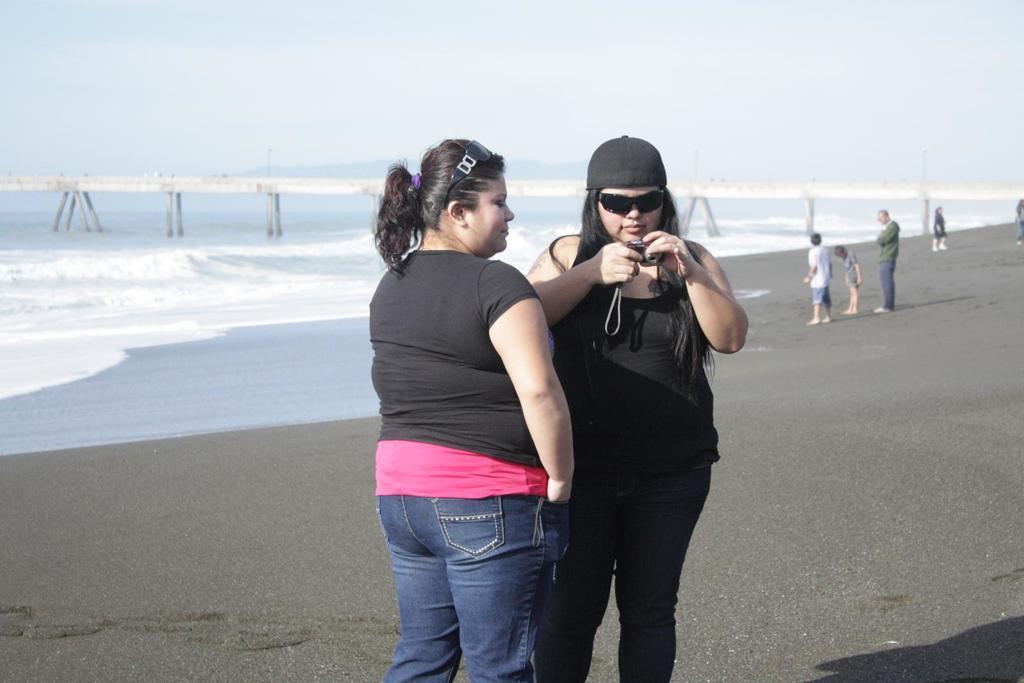Please provide a concise description of this image. Here in this picture, in the front we can see two women standing on the ground and both of them are smiling and the woman on the right side is wearing cap and goggles and holding a camera in her hand and behind them also we can see other number of people standing and we can see water present all over there and we can also see a bridge present behind them and we can see the sky is cloudy. 